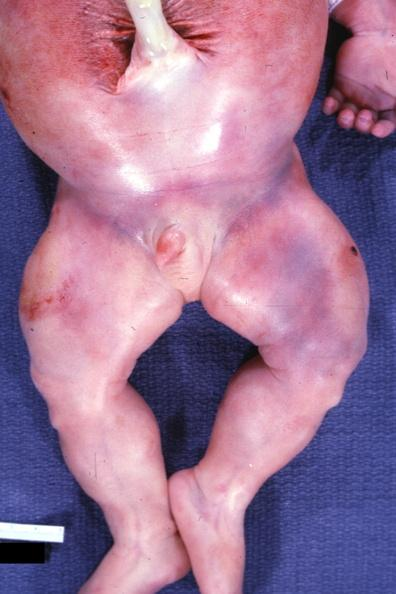s beckwith-wiedemann syndrome present?
Answer the question using a single word or phrase. Yes 